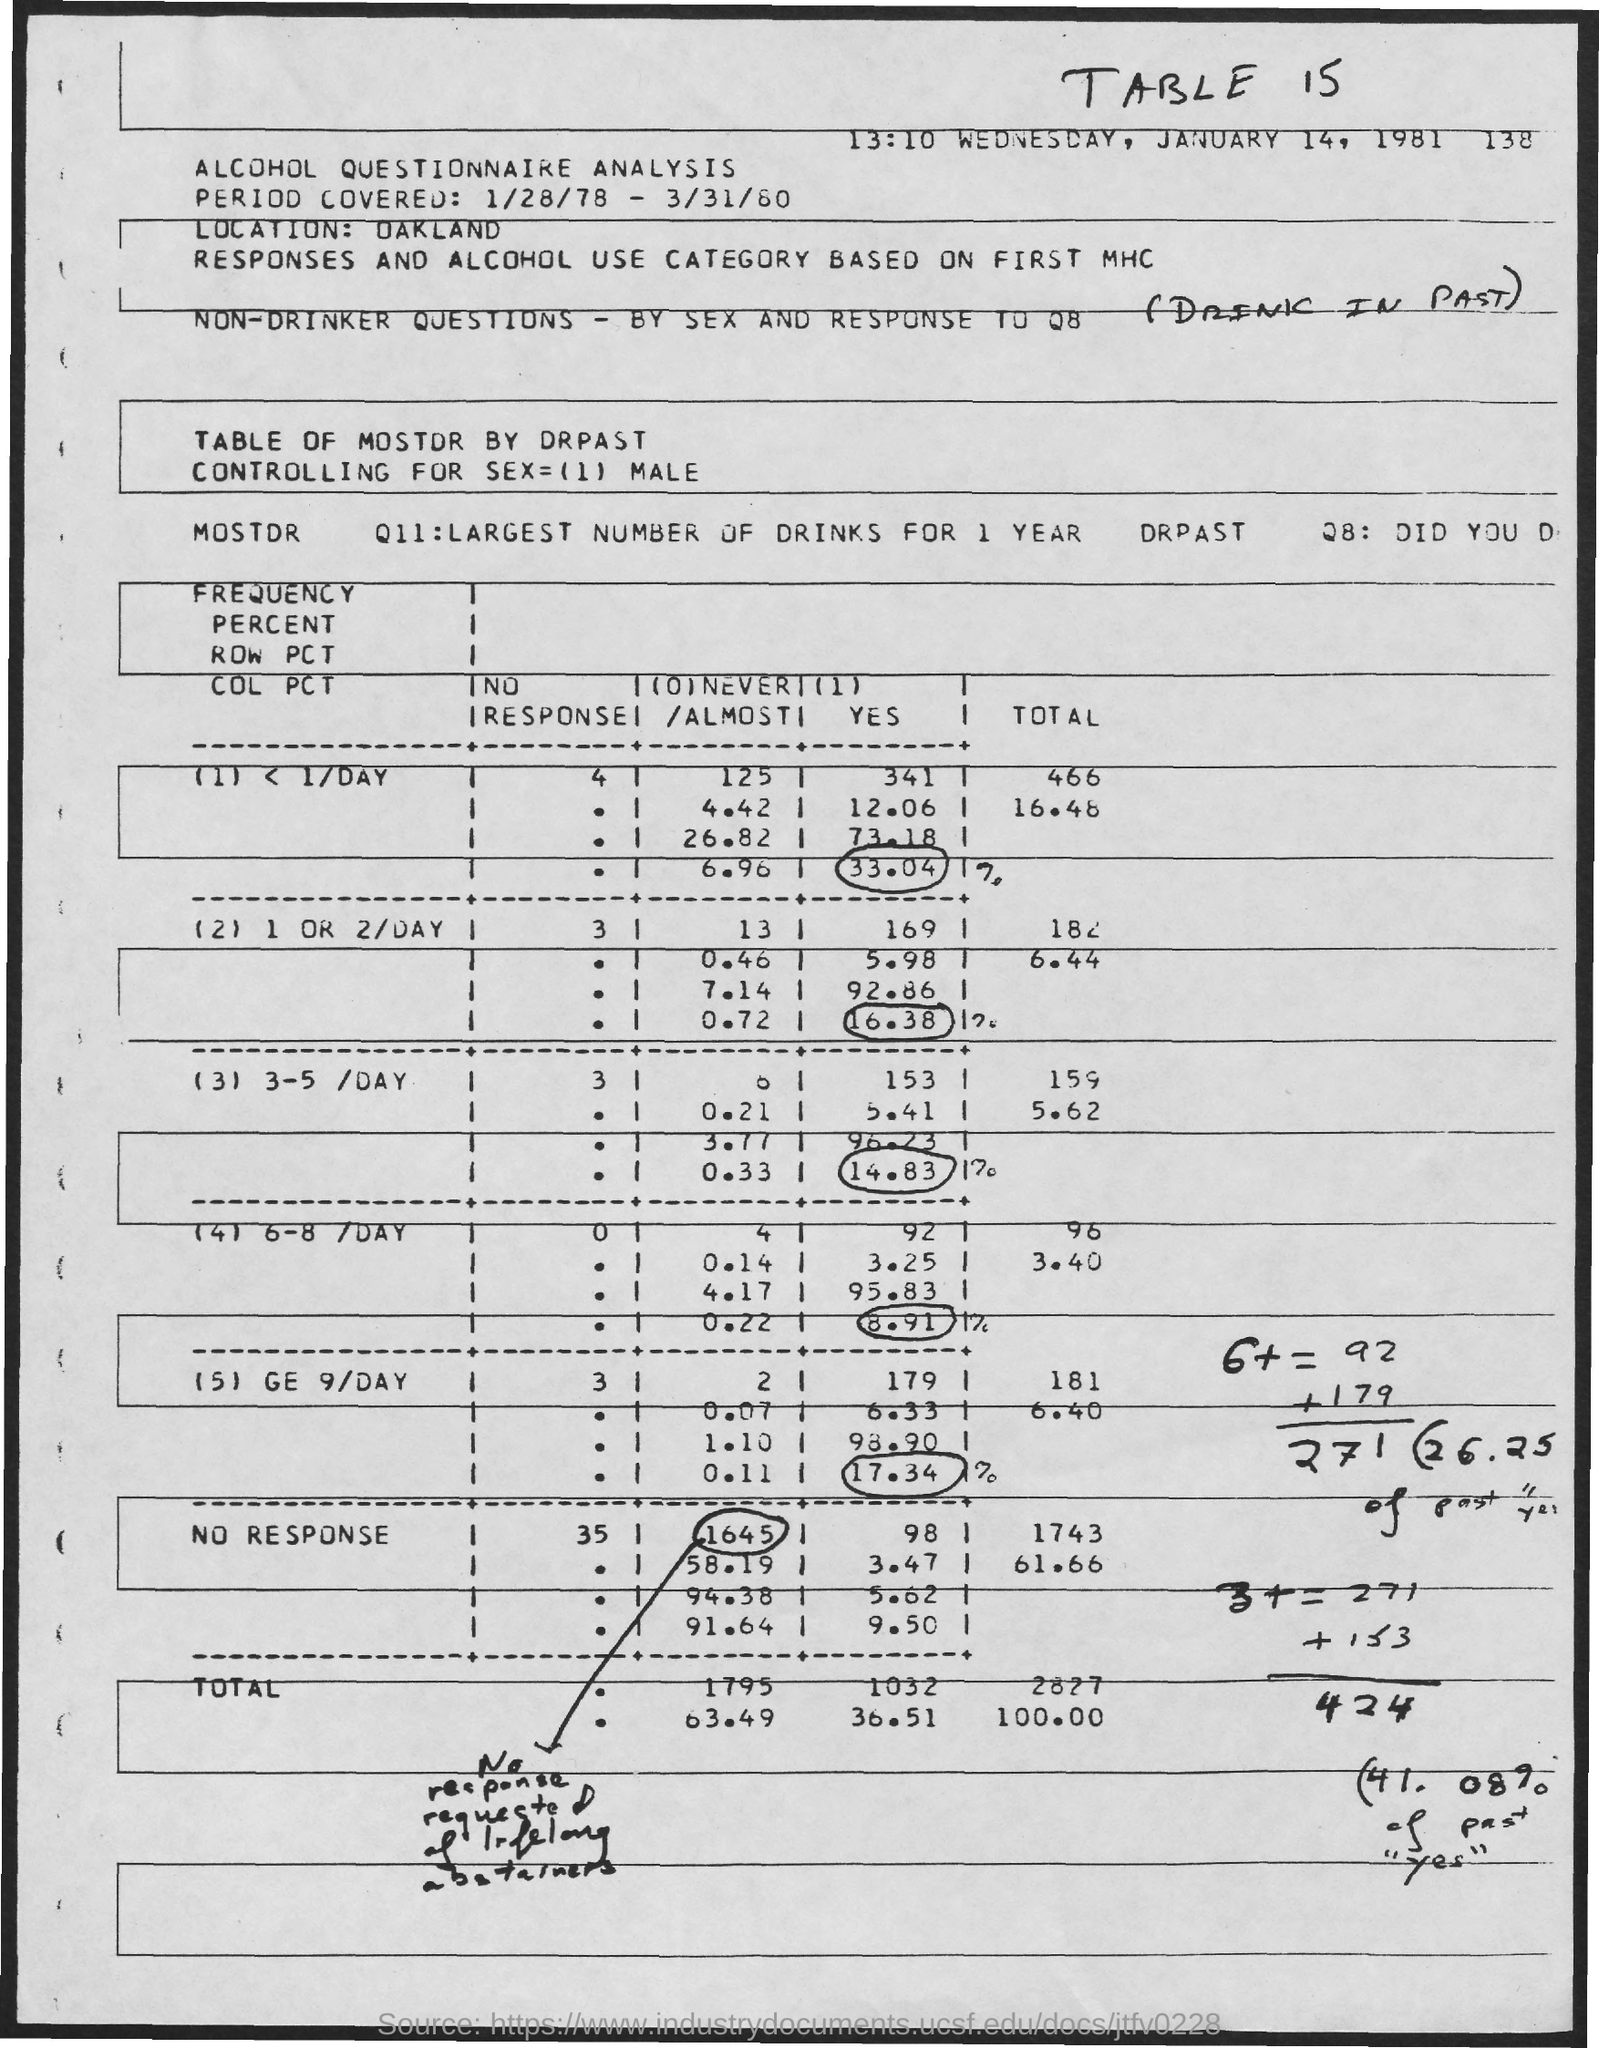Give some essential details in this illustration. The location is Oakland. The table number is 15. 